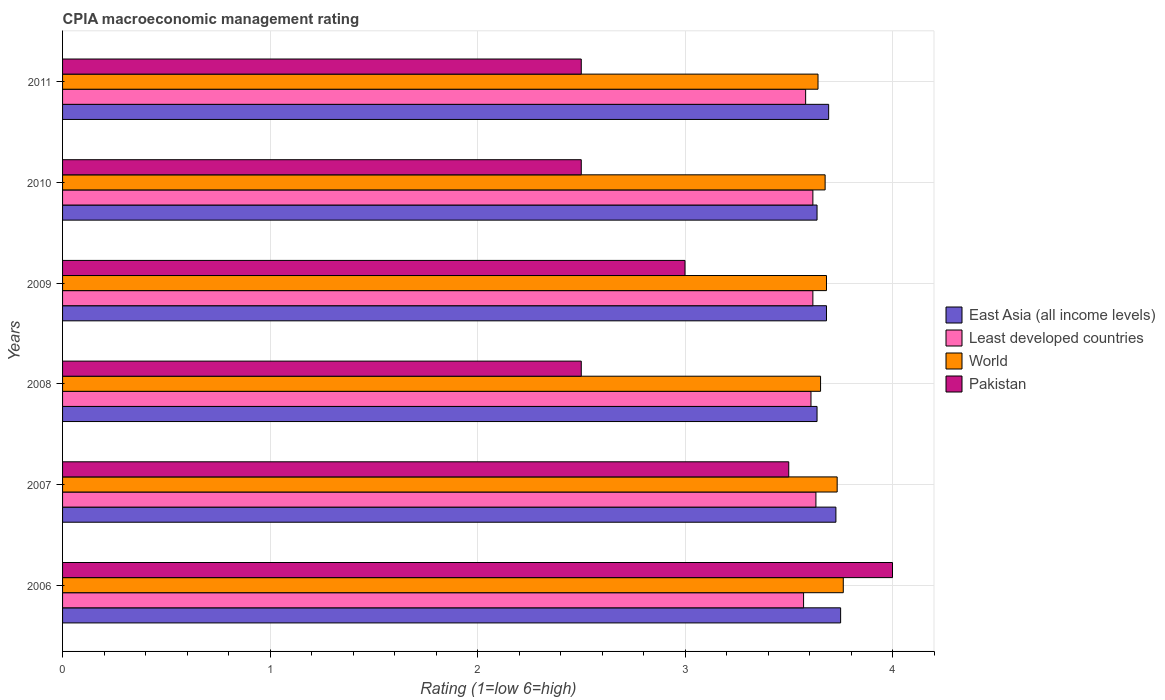How many different coloured bars are there?
Your response must be concise. 4. Are the number of bars on each tick of the Y-axis equal?
Your response must be concise. Yes. What is the label of the 4th group of bars from the top?
Keep it short and to the point. 2008. What is the CPIA rating in East Asia (all income levels) in 2011?
Ensure brevity in your answer.  3.69. Across all years, what is the maximum CPIA rating in East Asia (all income levels)?
Your answer should be compact. 3.75. Across all years, what is the minimum CPIA rating in Pakistan?
Give a very brief answer. 2.5. In which year was the CPIA rating in East Asia (all income levels) minimum?
Keep it short and to the point. 2008. What is the total CPIA rating in World in the graph?
Provide a succinct answer. 22.15. What is the difference between the CPIA rating in World in 2008 and that in 2010?
Make the answer very short. -0.02. What is the difference between the CPIA rating in East Asia (all income levels) in 2009 and the CPIA rating in Least developed countries in 2011?
Offer a very short reply. 0.1. What is the average CPIA rating in Least developed countries per year?
Keep it short and to the point. 3.6. In the year 2007, what is the difference between the CPIA rating in East Asia (all income levels) and CPIA rating in World?
Provide a short and direct response. -0.01. What is the ratio of the CPIA rating in Least developed countries in 2006 to that in 2010?
Offer a terse response. 0.99. What is the difference between the highest and the second highest CPIA rating in Pakistan?
Keep it short and to the point. 0.5. What is the difference between the highest and the lowest CPIA rating in World?
Offer a very short reply. 0.12. In how many years, is the CPIA rating in World greater than the average CPIA rating in World taken over all years?
Provide a succinct answer. 2. Is the sum of the CPIA rating in Least developed countries in 2007 and 2009 greater than the maximum CPIA rating in Pakistan across all years?
Offer a very short reply. Yes. Is it the case that in every year, the sum of the CPIA rating in World and CPIA rating in Least developed countries is greater than the sum of CPIA rating in East Asia (all income levels) and CPIA rating in Pakistan?
Offer a very short reply. No. What does the 4th bar from the bottom in 2011 represents?
Provide a short and direct response. Pakistan. How many bars are there?
Ensure brevity in your answer.  24. Where does the legend appear in the graph?
Offer a terse response. Center right. How are the legend labels stacked?
Ensure brevity in your answer.  Vertical. What is the title of the graph?
Offer a very short reply. CPIA macroeconomic management rating. Does "Gambia, The" appear as one of the legend labels in the graph?
Give a very brief answer. No. What is the label or title of the X-axis?
Your answer should be very brief. Rating (1=low 6=high). What is the Rating (1=low 6=high) of East Asia (all income levels) in 2006?
Offer a terse response. 3.75. What is the Rating (1=low 6=high) of Least developed countries in 2006?
Keep it short and to the point. 3.57. What is the Rating (1=low 6=high) of World in 2006?
Keep it short and to the point. 3.76. What is the Rating (1=low 6=high) in East Asia (all income levels) in 2007?
Keep it short and to the point. 3.73. What is the Rating (1=low 6=high) in Least developed countries in 2007?
Provide a succinct answer. 3.63. What is the Rating (1=low 6=high) of World in 2007?
Keep it short and to the point. 3.73. What is the Rating (1=low 6=high) in East Asia (all income levels) in 2008?
Give a very brief answer. 3.64. What is the Rating (1=low 6=high) in Least developed countries in 2008?
Make the answer very short. 3.61. What is the Rating (1=low 6=high) of World in 2008?
Your answer should be compact. 3.65. What is the Rating (1=low 6=high) in East Asia (all income levels) in 2009?
Give a very brief answer. 3.68. What is the Rating (1=low 6=high) in Least developed countries in 2009?
Offer a terse response. 3.62. What is the Rating (1=low 6=high) in World in 2009?
Offer a terse response. 3.68. What is the Rating (1=low 6=high) of Pakistan in 2009?
Your answer should be very brief. 3. What is the Rating (1=low 6=high) in East Asia (all income levels) in 2010?
Keep it short and to the point. 3.64. What is the Rating (1=low 6=high) of Least developed countries in 2010?
Offer a terse response. 3.62. What is the Rating (1=low 6=high) in World in 2010?
Keep it short and to the point. 3.68. What is the Rating (1=low 6=high) of Pakistan in 2010?
Your response must be concise. 2.5. What is the Rating (1=low 6=high) in East Asia (all income levels) in 2011?
Provide a short and direct response. 3.69. What is the Rating (1=low 6=high) in Least developed countries in 2011?
Your response must be concise. 3.58. What is the Rating (1=low 6=high) of World in 2011?
Ensure brevity in your answer.  3.64. What is the Rating (1=low 6=high) of Pakistan in 2011?
Offer a very short reply. 2.5. Across all years, what is the maximum Rating (1=low 6=high) of East Asia (all income levels)?
Provide a short and direct response. 3.75. Across all years, what is the maximum Rating (1=low 6=high) of Least developed countries?
Offer a very short reply. 3.63. Across all years, what is the maximum Rating (1=low 6=high) in World?
Keep it short and to the point. 3.76. Across all years, what is the maximum Rating (1=low 6=high) of Pakistan?
Your answer should be compact. 4. Across all years, what is the minimum Rating (1=low 6=high) of East Asia (all income levels)?
Ensure brevity in your answer.  3.64. Across all years, what is the minimum Rating (1=low 6=high) of Least developed countries?
Make the answer very short. 3.57. Across all years, what is the minimum Rating (1=low 6=high) in World?
Your response must be concise. 3.64. What is the total Rating (1=low 6=high) of East Asia (all income levels) in the graph?
Offer a very short reply. 22.12. What is the total Rating (1=low 6=high) of Least developed countries in the graph?
Your answer should be compact. 21.62. What is the total Rating (1=low 6=high) in World in the graph?
Provide a short and direct response. 22.15. What is the difference between the Rating (1=low 6=high) of East Asia (all income levels) in 2006 and that in 2007?
Make the answer very short. 0.02. What is the difference between the Rating (1=low 6=high) of Least developed countries in 2006 and that in 2007?
Ensure brevity in your answer.  -0.06. What is the difference between the Rating (1=low 6=high) of World in 2006 and that in 2007?
Give a very brief answer. 0.03. What is the difference between the Rating (1=low 6=high) in East Asia (all income levels) in 2006 and that in 2008?
Offer a terse response. 0.11. What is the difference between the Rating (1=low 6=high) in Least developed countries in 2006 and that in 2008?
Your answer should be very brief. -0.04. What is the difference between the Rating (1=low 6=high) in World in 2006 and that in 2008?
Ensure brevity in your answer.  0.11. What is the difference between the Rating (1=low 6=high) in East Asia (all income levels) in 2006 and that in 2009?
Provide a short and direct response. 0.07. What is the difference between the Rating (1=low 6=high) of Least developed countries in 2006 and that in 2009?
Give a very brief answer. -0.04. What is the difference between the Rating (1=low 6=high) of World in 2006 and that in 2009?
Provide a succinct answer. 0.08. What is the difference between the Rating (1=low 6=high) in East Asia (all income levels) in 2006 and that in 2010?
Give a very brief answer. 0.11. What is the difference between the Rating (1=low 6=high) in Least developed countries in 2006 and that in 2010?
Your response must be concise. -0.04. What is the difference between the Rating (1=low 6=high) of World in 2006 and that in 2010?
Offer a very short reply. 0.09. What is the difference between the Rating (1=low 6=high) of East Asia (all income levels) in 2006 and that in 2011?
Keep it short and to the point. 0.06. What is the difference between the Rating (1=low 6=high) in Least developed countries in 2006 and that in 2011?
Give a very brief answer. -0.01. What is the difference between the Rating (1=low 6=high) of World in 2006 and that in 2011?
Provide a short and direct response. 0.12. What is the difference between the Rating (1=low 6=high) in Pakistan in 2006 and that in 2011?
Give a very brief answer. 1.5. What is the difference between the Rating (1=low 6=high) in East Asia (all income levels) in 2007 and that in 2008?
Your response must be concise. 0.09. What is the difference between the Rating (1=low 6=high) of Least developed countries in 2007 and that in 2008?
Provide a short and direct response. 0.02. What is the difference between the Rating (1=low 6=high) of East Asia (all income levels) in 2007 and that in 2009?
Provide a succinct answer. 0.05. What is the difference between the Rating (1=low 6=high) in Least developed countries in 2007 and that in 2009?
Offer a terse response. 0.01. What is the difference between the Rating (1=low 6=high) of World in 2007 and that in 2009?
Offer a terse response. 0.05. What is the difference between the Rating (1=low 6=high) in Pakistan in 2007 and that in 2009?
Keep it short and to the point. 0.5. What is the difference between the Rating (1=low 6=high) in East Asia (all income levels) in 2007 and that in 2010?
Offer a terse response. 0.09. What is the difference between the Rating (1=low 6=high) in Least developed countries in 2007 and that in 2010?
Give a very brief answer. 0.01. What is the difference between the Rating (1=low 6=high) of World in 2007 and that in 2010?
Offer a very short reply. 0.06. What is the difference between the Rating (1=low 6=high) of East Asia (all income levels) in 2007 and that in 2011?
Offer a terse response. 0.04. What is the difference between the Rating (1=low 6=high) of Least developed countries in 2007 and that in 2011?
Make the answer very short. 0.05. What is the difference between the Rating (1=low 6=high) in World in 2007 and that in 2011?
Keep it short and to the point. 0.09. What is the difference between the Rating (1=low 6=high) of East Asia (all income levels) in 2008 and that in 2009?
Provide a succinct answer. -0.05. What is the difference between the Rating (1=low 6=high) in Least developed countries in 2008 and that in 2009?
Offer a very short reply. -0.01. What is the difference between the Rating (1=low 6=high) of World in 2008 and that in 2009?
Keep it short and to the point. -0.03. What is the difference between the Rating (1=low 6=high) of East Asia (all income levels) in 2008 and that in 2010?
Offer a terse response. 0. What is the difference between the Rating (1=low 6=high) in Least developed countries in 2008 and that in 2010?
Ensure brevity in your answer.  -0.01. What is the difference between the Rating (1=low 6=high) in World in 2008 and that in 2010?
Ensure brevity in your answer.  -0.02. What is the difference between the Rating (1=low 6=high) of East Asia (all income levels) in 2008 and that in 2011?
Your answer should be compact. -0.06. What is the difference between the Rating (1=low 6=high) in Least developed countries in 2008 and that in 2011?
Your answer should be very brief. 0.03. What is the difference between the Rating (1=low 6=high) of World in 2008 and that in 2011?
Your answer should be compact. 0.01. What is the difference between the Rating (1=low 6=high) in Pakistan in 2008 and that in 2011?
Your answer should be compact. 0. What is the difference between the Rating (1=low 6=high) in East Asia (all income levels) in 2009 and that in 2010?
Your answer should be very brief. 0.05. What is the difference between the Rating (1=low 6=high) in Least developed countries in 2009 and that in 2010?
Your answer should be compact. 0. What is the difference between the Rating (1=low 6=high) in World in 2009 and that in 2010?
Your answer should be very brief. 0.01. What is the difference between the Rating (1=low 6=high) of East Asia (all income levels) in 2009 and that in 2011?
Make the answer very short. -0.01. What is the difference between the Rating (1=low 6=high) of Least developed countries in 2009 and that in 2011?
Your response must be concise. 0.03. What is the difference between the Rating (1=low 6=high) in World in 2009 and that in 2011?
Give a very brief answer. 0.04. What is the difference between the Rating (1=low 6=high) of East Asia (all income levels) in 2010 and that in 2011?
Provide a short and direct response. -0.06. What is the difference between the Rating (1=low 6=high) of Least developed countries in 2010 and that in 2011?
Offer a very short reply. 0.03. What is the difference between the Rating (1=low 6=high) in World in 2010 and that in 2011?
Ensure brevity in your answer.  0.03. What is the difference between the Rating (1=low 6=high) in Pakistan in 2010 and that in 2011?
Your response must be concise. 0. What is the difference between the Rating (1=low 6=high) of East Asia (all income levels) in 2006 and the Rating (1=low 6=high) of Least developed countries in 2007?
Provide a short and direct response. 0.12. What is the difference between the Rating (1=low 6=high) in East Asia (all income levels) in 2006 and the Rating (1=low 6=high) in World in 2007?
Ensure brevity in your answer.  0.02. What is the difference between the Rating (1=low 6=high) in East Asia (all income levels) in 2006 and the Rating (1=low 6=high) in Pakistan in 2007?
Provide a short and direct response. 0.25. What is the difference between the Rating (1=low 6=high) of Least developed countries in 2006 and the Rating (1=low 6=high) of World in 2007?
Provide a succinct answer. -0.16. What is the difference between the Rating (1=low 6=high) in Least developed countries in 2006 and the Rating (1=low 6=high) in Pakistan in 2007?
Make the answer very short. 0.07. What is the difference between the Rating (1=low 6=high) in World in 2006 and the Rating (1=low 6=high) in Pakistan in 2007?
Give a very brief answer. 0.26. What is the difference between the Rating (1=low 6=high) of East Asia (all income levels) in 2006 and the Rating (1=low 6=high) of Least developed countries in 2008?
Offer a terse response. 0.14. What is the difference between the Rating (1=low 6=high) of East Asia (all income levels) in 2006 and the Rating (1=low 6=high) of World in 2008?
Your answer should be very brief. 0.1. What is the difference between the Rating (1=low 6=high) in East Asia (all income levels) in 2006 and the Rating (1=low 6=high) in Pakistan in 2008?
Make the answer very short. 1.25. What is the difference between the Rating (1=low 6=high) in Least developed countries in 2006 and the Rating (1=low 6=high) in World in 2008?
Offer a very short reply. -0.08. What is the difference between the Rating (1=low 6=high) in Least developed countries in 2006 and the Rating (1=low 6=high) in Pakistan in 2008?
Offer a very short reply. 1.07. What is the difference between the Rating (1=low 6=high) of World in 2006 and the Rating (1=low 6=high) of Pakistan in 2008?
Give a very brief answer. 1.26. What is the difference between the Rating (1=low 6=high) in East Asia (all income levels) in 2006 and the Rating (1=low 6=high) in Least developed countries in 2009?
Your response must be concise. 0.13. What is the difference between the Rating (1=low 6=high) in East Asia (all income levels) in 2006 and the Rating (1=low 6=high) in World in 2009?
Offer a terse response. 0.07. What is the difference between the Rating (1=low 6=high) of Least developed countries in 2006 and the Rating (1=low 6=high) of World in 2009?
Keep it short and to the point. -0.11. What is the difference between the Rating (1=low 6=high) in World in 2006 and the Rating (1=low 6=high) in Pakistan in 2009?
Offer a terse response. 0.76. What is the difference between the Rating (1=low 6=high) of East Asia (all income levels) in 2006 and the Rating (1=low 6=high) of Least developed countries in 2010?
Give a very brief answer. 0.13. What is the difference between the Rating (1=low 6=high) of East Asia (all income levels) in 2006 and the Rating (1=low 6=high) of World in 2010?
Provide a succinct answer. 0.07. What is the difference between the Rating (1=low 6=high) in East Asia (all income levels) in 2006 and the Rating (1=low 6=high) in Pakistan in 2010?
Ensure brevity in your answer.  1.25. What is the difference between the Rating (1=low 6=high) in Least developed countries in 2006 and the Rating (1=low 6=high) in World in 2010?
Ensure brevity in your answer.  -0.1. What is the difference between the Rating (1=low 6=high) of Least developed countries in 2006 and the Rating (1=low 6=high) of Pakistan in 2010?
Make the answer very short. 1.07. What is the difference between the Rating (1=low 6=high) of World in 2006 and the Rating (1=low 6=high) of Pakistan in 2010?
Provide a succinct answer. 1.26. What is the difference between the Rating (1=low 6=high) of East Asia (all income levels) in 2006 and the Rating (1=low 6=high) of Least developed countries in 2011?
Keep it short and to the point. 0.17. What is the difference between the Rating (1=low 6=high) in East Asia (all income levels) in 2006 and the Rating (1=low 6=high) in World in 2011?
Give a very brief answer. 0.11. What is the difference between the Rating (1=low 6=high) of Least developed countries in 2006 and the Rating (1=low 6=high) of World in 2011?
Ensure brevity in your answer.  -0.07. What is the difference between the Rating (1=low 6=high) in Least developed countries in 2006 and the Rating (1=low 6=high) in Pakistan in 2011?
Your response must be concise. 1.07. What is the difference between the Rating (1=low 6=high) in World in 2006 and the Rating (1=low 6=high) in Pakistan in 2011?
Offer a terse response. 1.26. What is the difference between the Rating (1=low 6=high) of East Asia (all income levels) in 2007 and the Rating (1=low 6=high) of Least developed countries in 2008?
Your answer should be compact. 0.12. What is the difference between the Rating (1=low 6=high) of East Asia (all income levels) in 2007 and the Rating (1=low 6=high) of World in 2008?
Give a very brief answer. 0.07. What is the difference between the Rating (1=low 6=high) in East Asia (all income levels) in 2007 and the Rating (1=low 6=high) in Pakistan in 2008?
Ensure brevity in your answer.  1.23. What is the difference between the Rating (1=low 6=high) of Least developed countries in 2007 and the Rating (1=low 6=high) of World in 2008?
Provide a short and direct response. -0.02. What is the difference between the Rating (1=low 6=high) in Least developed countries in 2007 and the Rating (1=low 6=high) in Pakistan in 2008?
Ensure brevity in your answer.  1.13. What is the difference between the Rating (1=low 6=high) in World in 2007 and the Rating (1=low 6=high) in Pakistan in 2008?
Offer a very short reply. 1.23. What is the difference between the Rating (1=low 6=high) of East Asia (all income levels) in 2007 and the Rating (1=low 6=high) of Least developed countries in 2009?
Provide a short and direct response. 0.11. What is the difference between the Rating (1=low 6=high) of East Asia (all income levels) in 2007 and the Rating (1=low 6=high) of World in 2009?
Offer a terse response. 0.05. What is the difference between the Rating (1=low 6=high) in East Asia (all income levels) in 2007 and the Rating (1=low 6=high) in Pakistan in 2009?
Your answer should be very brief. 0.73. What is the difference between the Rating (1=low 6=high) in Least developed countries in 2007 and the Rating (1=low 6=high) in World in 2009?
Provide a succinct answer. -0.05. What is the difference between the Rating (1=low 6=high) of Least developed countries in 2007 and the Rating (1=low 6=high) of Pakistan in 2009?
Keep it short and to the point. 0.63. What is the difference between the Rating (1=low 6=high) of World in 2007 and the Rating (1=low 6=high) of Pakistan in 2009?
Your answer should be compact. 0.73. What is the difference between the Rating (1=low 6=high) in East Asia (all income levels) in 2007 and the Rating (1=low 6=high) in Least developed countries in 2010?
Provide a short and direct response. 0.11. What is the difference between the Rating (1=low 6=high) of East Asia (all income levels) in 2007 and the Rating (1=low 6=high) of World in 2010?
Ensure brevity in your answer.  0.05. What is the difference between the Rating (1=low 6=high) in East Asia (all income levels) in 2007 and the Rating (1=low 6=high) in Pakistan in 2010?
Make the answer very short. 1.23. What is the difference between the Rating (1=low 6=high) of Least developed countries in 2007 and the Rating (1=low 6=high) of World in 2010?
Ensure brevity in your answer.  -0.04. What is the difference between the Rating (1=low 6=high) in Least developed countries in 2007 and the Rating (1=low 6=high) in Pakistan in 2010?
Ensure brevity in your answer.  1.13. What is the difference between the Rating (1=low 6=high) in World in 2007 and the Rating (1=low 6=high) in Pakistan in 2010?
Provide a succinct answer. 1.23. What is the difference between the Rating (1=low 6=high) of East Asia (all income levels) in 2007 and the Rating (1=low 6=high) of Least developed countries in 2011?
Provide a succinct answer. 0.15. What is the difference between the Rating (1=low 6=high) of East Asia (all income levels) in 2007 and the Rating (1=low 6=high) of World in 2011?
Ensure brevity in your answer.  0.09. What is the difference between the Rating (1=low 6=high) of East Asia (all income levels) in 2007 and the Rating (1=low 6=high) of Pakistan in 2011?
Your response must be concise. 1.23. What is the difference between the Rating (1=low 6=high) of Least developed countries in 2007 and the Rating (1=low 6=high) of World in 2011?
Offer a terse response. -0.01. What is the difference between the Rating (1=low 6=high) of Least developed countries in 2007 and the Rating (1=low 6=high) of Pakistan in 2011?
Your answer should be very brief. 1.13. What is the difference between the Rating (1=low 6=high) in World in 2007 and the Rating (1=low 6=high) in Pakistan in 2011?
Offer a terse response. 1.23. What is the difference between the Rating (1=low 6=high) in East Asia (all income levels) in 2008 and the Rating (1=low 6=high) in Least developed countries in 2009?
Offer a very short reply. 0.02. What is the difference between the Rating (1=low 6=high) in East Asia (all income levels) in 2008 and the Rating (1=low 6=high) in World in 2009?
Make the answer very short. -0.05. What is the difference between the Rating (1=low 6=high) of East Asia (all income levels) in 2008 and the Rating (1=low 6=high) of Pakistan in 2009?
Offer a very short reply. 0.64. What is the difference between the Rating (1=low 6=high) of Least developed countries in 2008 and the Rating (1=low 6=high) of World in 2009?
Your answer should be very brief. -0.07. What is the difference between the Rating (1=low 6=high) in Least developed countries in 2008 and the Rating (1=low 6=high) in Pakistan in 2009?
Ensure brevity in your answer.  0.61. What is the difference between the Rating (1=low 6=high) in World in 2008 and the Rating (1=low 6=high) in Pakistan in 2009?
Provide a short and direct response. 0.65. What is the difference between the Rating (1=low 6=high) in East Asia (all income levels) in 2008 and the Rating (1=low 6=high) in Least developed countries in 2010?
Offer a very short reply. 0.02. What is the difference between the Rating (1=low 6=high) in East Asia (all income levels) in 2008 and the Rating (1=low 6=high) in World in 2010?
Offer a terse response. -0.04. What is the difference between the Rating (1=low 6=high) in East Asia (all income levels) in 2008 and the Rating (1=low 6=high) in Pakistan in 2010?
Ensure brevity in your answer.  1.14. What is the difference between the Rating (1=low 6=high) of Least developed countries in 2008 and the Rating (1=low 6=high) of World in 2010?
Make the answer very short. -0.07. What is the difference between the Rating (1=low 6=high) in Least developed countries in 2008 and the Rating (1=low 6=high) in Pakistan in 2010?
Provide a succinct answer. 1.11. What is the difference between the Rating (1=low 6=high) in World in 2008 and the Rating (1=low 6=high) in Pakistan in 2010?
Offer a very short reply. 1.15. What is the difference between the Rating (1=low 6=high) of East Asia (all income levels) in 2008 and the Rating (1=low 6=high) of Least developed countries in 2011?
Offer a terse response. 0.06. What is the difference between the Rating (1=low 6=high) of East Asia (all income levels) in 2008 and the Rating (1=low 6=high) of World in 2011?
Provide a succinct answer. -0. What is the difference between the Rating (1=low 6=high) in East Asia (all income levels) in 2008 and the Rating (1=low 6=high) in Pakistan in 2011?
Your answer should be compact. 1.14. What is the difference between the Rating (1=low 6=high) in Least developed countries in 2008 and the Rating (1=low 6=high) in World in 2011?
Offer a very short reply. -0.03. What is the difference between the Rating (1=low 6=high) in Least developed countries in 2008 and the Rating (1=low 6=high) in Pakistan in 2011?
Keep it short and to the point. 1.11. What is the difference between the Rating (1=low 6=high) in World in 2008 and the Rating (1=low 6=high) in Pakistan in 2011?
Ensure brevity in your answer.  1.15. What is the difference between the Rating (1=low 6=high) of East Asia (all income levels) in 2009 and the Rating (1=low 6=high) of Least developed countries in 2010?
Make the answer very short. 0.07. What is the difference between the Rating (1=low 6=high) of East Asia (all income levels) in 2009 and the Rating (1=low 6=high) of World in 2010?
Give a very brief answer. 0.01. What is the difference between the Rating (1=low 6=high) of East Asia (all income levels) in 2009 and the Rating (1=low 6=high) of Pakistan in 2010?
Make the answer very short. 1.18. What is the difference between the Rating (1=low 6=high) of Least developed countries in 2009 and the Rating (1=low 6=high) of World in 2010?
Ensure brevity in your answer.  -0.06. What is the difference between the Rating (1=low 6=high) of Least developed countries in 2009 and the Rating (1=low 6=high) of Pakistan in 2010?
Keep it short and to the point. 1.12. What is the difference between the Rating (1=low 6=high) of World in 2009 and the Rating (1=low 6=high) of Pakistan in 2010?
Offer a very short reply. 1.18. What is the difference between the Rating (1=low 6=high) of East Asia (all income levels) in 2009 and the Rating (1=low 6=high) of Least developed countries in 2011?
Make the answer very short. 0.1. What is the difference between the Rating (1=low 6=high) of East Asia (all income levels) in 2009 and the Rating (1=low 6=high) of World in 2011?
Your answer should be very brief. 0.04. What is the difference between the Rating (1=low 6=high) of East Asia (all income levels) in 2009 and the Rating (1=low 6=high) of Pakistan in 2011?
Your answer should be compact. 1.18. What is the difference between the Rating (1=low 6=high) in Least developed countries in 2009 and the Rating (1=low 6=high) in World in 2011?
Your answer should be very brief. -0.02. What is the difference between the Rating (1=low 6=high) in Least developed countries in 2009 and the Rating (1=low 6=high) in Pakistan in 2011?
Your answer should be compact. 1.12. What is the difference between the Rating (1=low 6=high) of World in 2009 and the Rating (1=low 6=high) of Pakistan in 2011?
Give a very brief answer. 1.18. What is the difference between the Rating (1=low 6=high) of East Asia (all income levels) in 2010 and the Rating (1=low 6=high) of Least developed countries in 2011?
Keep it short and to the point. 0.06. What is the difference between the Rating (1=low 6=high) in East Asia (all income levels) in 2010 and the Rating (1=low 6=high) in World in 2011?
Provide a short and direct response. -0. What is the difference between the Rating (1=low 6=high) of East Asia (all income levels) in 2010 and the Rating (1=low 6=high) of Pakistan in 2011?
Provide a succinct answer. 1.14. What is the difference between the Rating (1=low 6=high) in Least developed countries in 2010 and the Rating (1=low 6=high) in World in 2011?
Keep it short and to the point. -0.02. What is the difference between the Rating (1=low 6=high) in Least developed countries in 2010 and the Rating (1=low 6=high) in Pakistan in 2011?
Ensure brevity in your answer.  1.12. What is the difference between the Rating (1=low 6=high) of World in 2010 and the Rating (1=low 6=high) of Pakistan in 2011?
Make the answer very short. 1.18. What is the average Rating (1=low 6=high) in East Asia (all income levels) per year?
Your answer should be very brief. 3.69. What is the average Rating (1=low 6=high) of Least developed countries per year?
Your response must be concise. 3.6. What is the average Rating (1=low 6=high) in World per year?
Your response must be concise. 3.69. What is the average Rating (1=low 6=high) of Pakistan per year?
Provide a short and direct response. 3. In the year 2006, what is the difference between the Rating (1=low 6=high) in East Asia (all income levels) and Rating (1=low 6=high) in Least developed countries?
Provide a succinct answer. 0.18. In the year 2006, what is the difference between the Rating (1=low 6=high) of East Asia (all income levels) and Rating (1=low 6=high) of World?
Keep it short and to the point. -0.01. In the year 2006, what is the difference between the Rating (1=low 6=high) of East Asia (all income levels) and Rating (1=low 6=high) of Pakistan?
Your answer should be very brief. -0.25. In the year 2006, what is the difference between the Rating (1=low 6=high) in Least developed countries and Rating (1=low 6=high) in World?
Provide a succinct answer. -0.19. In the year 2006, what is the difference between the Rating (1=low 6=high) in Least developed countries and Rating (1=low 6=high) in Pakistan?
Offer a terse response. -0.43. In the year 2006, what is the difference between the Rating (1=low 6=high) of World and Rating (1=low 6=high) of Pakistan?
Offer a terse response. -0.24. In the year 2007, what is the difference between the Rating (1=low 6=high) in East Asia (all income levels) and Rating (1=low 6=high) in Least developed countries?
Make the answer very short. 0.1. In the year 2007, what is the difference between the Rating (1=low 6=high) in East Asia (all income levels) and Rating (1=low 6=high) in World?
Offer a terse response. -0.01. In the year 2007, what is the difference between the Rating (1=low 6=high) in East Asia (all income levels) and Rating (1=low 6=high) in Pakistan?
Make the answer very short. 0.23. In the year 2007, what is the difference between the Rating (1=low 6=high) in Least developed countries and Rating (1=low 6=high) in World?
Provide a succinct answer. -0.1. In the year 2007, what is the difference between the Rating (1=low 6=high) in Least developed countries and Rating (1=low 6=high) in Pakistan?
Offer a terse response. 0.13. In the year 2007, what is the difference between the Rating (1=low 6=high) in World and Rating (1=low 6=high) in Pakistan?
Give a very brief answer. 0.23. In the year 2008, what is the difference between the Rating (1=low 6=high) in East Asia (all income levels) and Rating (1=low 6=high) in Least developed countries?
Offer a very short reply. 0.03. In the year 2008, what is the difference between the Rating (1=low 6=high) in East Asia (all income levels) and Rating (1=low 6=high) in World?
Your answer should be very brief. -0.02. In the year 2008, what is the difference between the Rating (1=low 6=high) of East Asia (all income levels) and Rating (1=low 6=high) of Pakistan?
Your answer should be very brief. 1.14. In the year 2008, what is the difference between the Rating (1=low 6=high) of Least developed countries and Rating (1=low 6=high) of World?
Make the answer very short. -0.05. In the year 2008, what is the difference between the Rating (1=low 6=high) of Least developed countries and Rating (1=low 6=high) of Pakistan?
Your response must be concise. 1.11. In the year 2008, what is the difference between the Rating (1=low 6=high) of World and Rating (1=low 6=high) of Pakistan?
Offer a very short reply. 1.15. In the year 2009, what is the difference between the Rating (1=low 6=high) in East Asia (all income levels) and Rating (1=low 6=high) in Least developed countries?
Your answer should be compact. 0.07. In the year 2009, what is the difference between the Rating (1=low 6=high) in East Asia (all income levels) and Rating (1=low 6=high) in Pakistan?
Give a very brief answer. 0.68. In the year 2009, what is the difference between the Rating (1=low 6=high) of Least developed countries and Rating (1=low 6=high) of World?
Keep it short and to the point. -0.07. In the year 2009, what is the difference between the Rating (1=low 6=high) in Least developed countries and Rating (1=low 6=high) in Pakistan?
Your answer should be compact. 0.62. In the year 2009, what is the difference between the Rating (1=low 6=high) of World and Rating (1=low 6=high) of Pakistan?
Give a very brief answer. 0.68. In the year 2010, what is the difference between the Rating (1=low 6=high) of East Asia (all income levels) and Rating (1=low 6=high) of Least developed countries?
Provide a short and direct response. 0.02. In the year 2010, what is the difference between the Rating (1=low 6=high) in East Asia (all income levels) and Rating (1=low 6=high) in World?
Your answer should be compact. -0.04. In the year 2010, what is the difference between the Rating (1=low 6=high) of East Asia (all income levels) and Rating (1=low 6=high) of Pakistan?
Your answer should be very brief. 1.14. In the year 2010, what is the difference between the Rating (1=low 6=high) in Least developed countries and Rating (1=low 6=high) in World?
Provide a short and direct response. -0.06. In the year 2010, what is the difference between the Rating (1=low 6=high) in Least developed countries and Rating (1=low 6=high) in Pakistan?
Provide a succinct answer. 1.12. In the year 2010, what is the difference between the Rating (1=low 6=high) of World and Rating (1=low 6=high) of Pakistan?
Ensure brevity in your answer.  1.18. In the year 2011, what is the difference between the Rating (1=low 6=high) in East Asia (all income levels) and Rating (1=low 6=high) in Least developed countries?
Offer a very short reply. 0.11. In the year 2011, what is the difference between the Rating (1=low 6=high) in East Asia (all income levels) and Rating (1=low 6=high) in World?
Your response must be concise. 0.05. In the year 2011, what is the difference between the Rating (1=low 6=high) in East Asia (all income levels) and Rating (1=low 6=high) in Pakistan?
Make the answer very short. 1.19. In the year 2011, what is the difference between the Rating (1=low 6=high) of Least developed countries and Rating (1=low 6=high) of World?
Provide a short and direct response. -0.06. In the year 2011, what is the difference between the Rating (1=low 6=high) in Least developed countries and Rating (1=low 6=high) in Pakistan?
Your answer should be compact. 1.08. In the year 2011, what is the difference between the Rating (1=low 6=high) of World and Rating (1=low 6=high) of Pakistan?
Offer a very short reply. 1.14. What is the ratio of the Rating (1=low 6=high) of Least developed countries in 2006 to that in 2007?
Your answer should be compact. 0.98. What is the ratio of the Rating (1=low 6=high) in World in 2006 to that in 2007?
Provide a succinct answer. 1.01. What is the ratio of the Rating (1=low 6=high) of Pakistan in 2006 to that in 2007?
Make the answer very short. 1.14. What is the ratio of the Rating (1=low 6=high) in East Asia (all income levels) in 2006 to that in 2008?
Your answer should be compact. 1.03. What is the ratio of the Rating (1=low 6=high) in Least developed countries in 2006 to that in 2008?
Give a very brief answer. 0.99. What is the ratio of the Rating (1=low 6=high) in World in 2006 to that in 2008?
Your answer should be compact. 1.03. What is the ratio of the Rating (1=low 6=high) in Pakistan in 2006 to that in 2008?
Your answer should be very brief. 1.6. What is the ratio of the Rating (1=low 6=high) in East Asia (all income levels) in 2006 to that in 2009?
Your answer should be compact. 1.02. What is the ratio of the Rating (1=low 6=high) in Least developed countries in 2006 to that in 2009?
Provide a succinct answer. 0.99. What is the ratio of the Rating (1=low 6=high) in East Asia (all income levels) in 2006 to that in 2010?
Offer a very short reply. 1.03. What is the ratio of the Rating (1=low 6=high) of Least developed countries in 2006 to that in 2010?
Give a very brief answer. 0.99. What is the ratio of the Rating (1=low 6=high) of World in 2006 to that in 2010?
Give a very brief answer. 1.02. What is the ratio of the Rating (1=low 6=high) of East Asia (all income levels) in 2006 to that in 2011?
Keep it short and to the point. 1.02. What is the ratio of the Rating (1=low 6=high) of Least developed countries in 2006 to that in 2011?
Your answer should be very brief. 1. What is the ratio of the Rating (1=low 6=high) of World in 2006 to that in 2011?
Make the answer very short. 1.03. What is the ratio of the Rating (1=low 6=high) of Least developed countries in 2007 to that in 2008?
Your answer should be very brief. 1.01. What is the ratio of the Rating (1=low 6=high) in World in 2007 to that in 2008?
Keep it short and to the point. 1.02. What is the ratio of the Rating (1=low 6=high) in East Asia (all income levels) in 2007 to that in 2009?
Provide a short and direct response. 1.01. What is the ratio of the Rating (1=low 6=high) in Pakistan in 2007 to that in 2009?
Keep it short and to the point. 1.17. What is the ratio of the Rating (1=low 6=high) of East Asia (all income levels) in 2007 to that in 2010?
Ensure brevity in your answer.  1.02. What is the ratio of the Rating (1=low 6=high) in World in 2007 to that in 2010?
Provide a short and direct response. 1.02. What is the ratio of the Rating (1=low 6=high) of Pakistan in 2007 to that in 2010?
Your answer should be compact. 1.4. What is the ratio of the Rating (1=low 6=high) in East Asia (all income levels) in 2007 to that in 2011?
Your answer should be very brief. 1.01. What is the ratio of the Rating (1=low 6=high) in Least developed countries in 2007 to that in 2011?
Your answer should be very brief. 1.01. What is the ratio of the Rating (1=low 6=high) in World in 2007 to that in 2011?
Provide a short and direct response. 1.03. What is the ratio of the Rating (1=low 6=high) of Pakistan in 2007 to that in 2011?
Your response must be concise. 1.4. What is the ratio of the Rating (1=low 6=high) of East Asia (all income levels) in 2008 to that in 2009?
Offer a terse response. 0.99. What is the ratio of the Rating (1=low 6=high) in Least developed countries in 2008 to that in 2009?
Your answer should be very brief. 1. What is the ratio of the Rating (1=low 6=high) of Pakistan in 2008 to that in 2009?
Provide a succinct answer. 0.83. What is the ratio of the Rating (1=low 6=high) in Least developed countries in 2008 to that in 2010?
Provide a succinct answer. 1. What is the ratio of the Rating (1=low 6=high) of World in 2008 to that in 2010?
Provide a short and direct response. 0.99. What is the ratio of the Rating (1=low 6=high) in Pakistan in 2008 to that in 2011?
Offer a very short reply. 1. What is the ratio of the Rating (1=low 6=high) in East Asia (all income levels) in 2009 to that in 2010?
Offer a very short reply. 1.01. What is the ratio of the Rating (1=low 6=high) of Least developed countries in 2009 to that in 2010?
Your response must be concise. 1. What is the ratio of the Rating (1=low 6=high) of Least developed countries in 2009 to that in 2011?
Make the answer very short. 1.01. What is the ratio of the Rating (1=low 6=high) of World in 2009 to that in 2011?
Give a very brief answer. 1.01. What is the ratio of the Rating (1=low 6=high) in Pakistan in 2009 to that in 2011?
Provide a succinct answer. 1.2. What is the ratio of the Rating (1=low 6=high) in Least developed countries in 2010 to that in 2011?
Provide a succinct answer. 1.01. What is the ratio of the Rating (1=low 6=high) in World in 2010 to that in 2011?
Offer a terse response. 1.01. What is the ratio of the Rating (1=low 6=high) in Pakistan in 2010 to that in 2011?
Make the answer very short. 1. What is the difference between the highest and the second highest Rating (1=low 6=high) in East Asia (all income levels)?
Your response must be concise. 0.02. What is the difference between the highest and the second highest Rating (1=low 6=high) in Least developed countries?
Make the answer very short. 0.01. What is the difference between the highest and the second highest Rating (1=low 6=high) in World?
Your answer should be very brief. 0.03. What is the difference between the highest and the lowest Rating (1=low 6=high) of East Asia (all income levels)?
Ensure brevity in your answer.  0.11. What is the difference between the highest and the lowest Rating (1=low 6=high) of Least developed countries?
Ensure brevity in your answer.  0.06. What is the difference between the highest and the lowest Rating (1=low 6=high) of World?
Ensure brevity in your answer.  0.12. What is the difference between the highest and the lowest Rating (1=low 6=high) in Pakistan?
Ensure brevity in your answer.  1.5. 